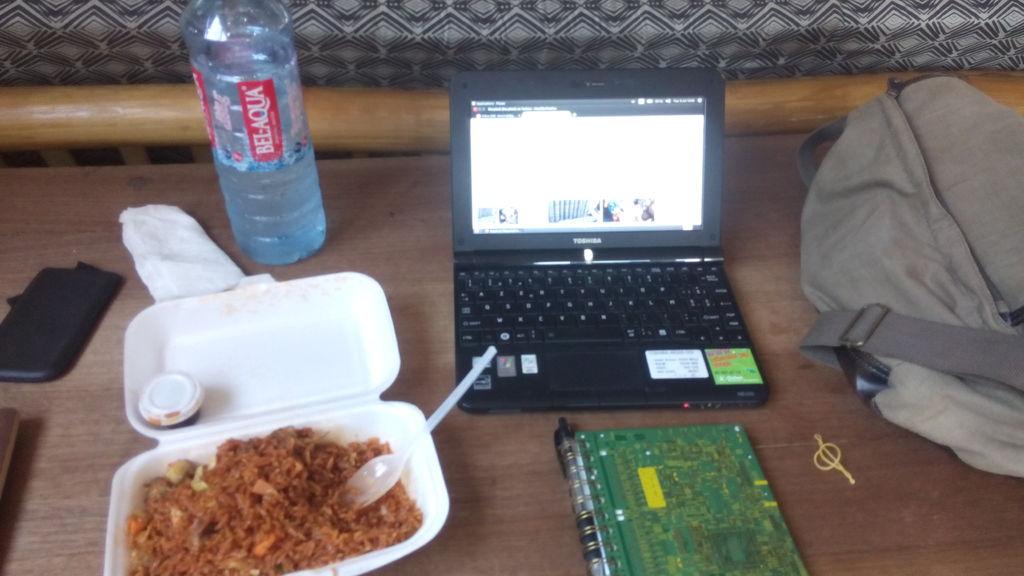Is the brand visible on that bottle water?
Your response must be concise. Yes. 